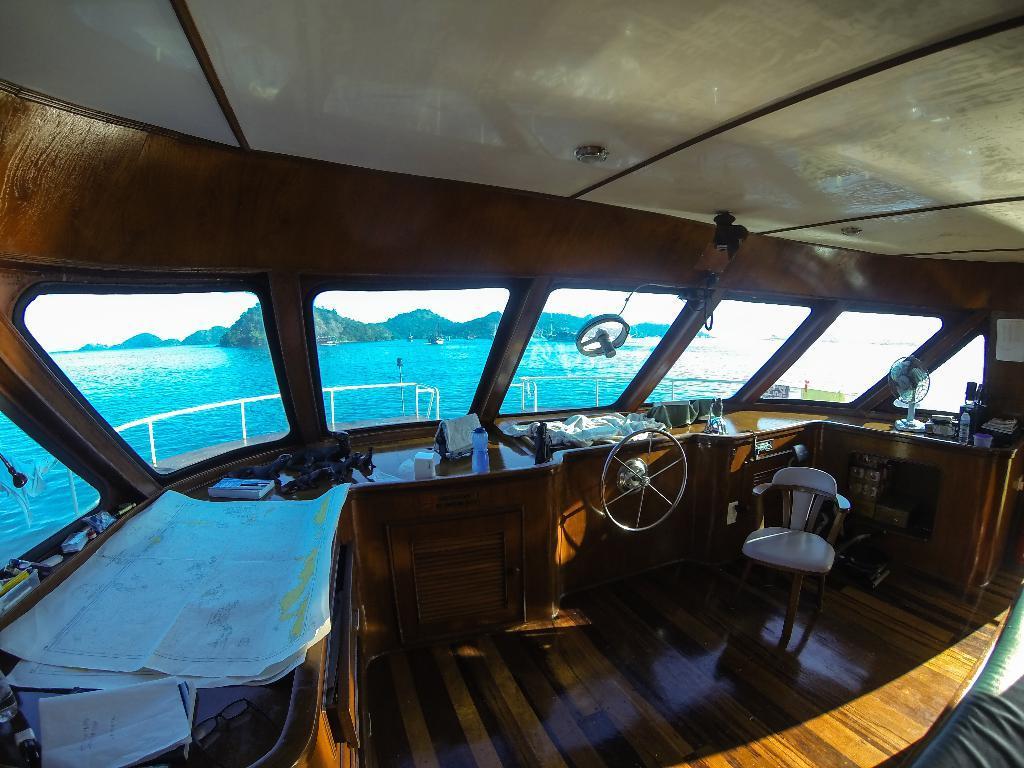Can you describe this image briefly? In this image I can see inside view of a boat. Here I can see water and mountains. 